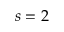Convert formula to latex. <formula><loc_0><loc_0><loc_500><loc_500>s = 2</formula> 